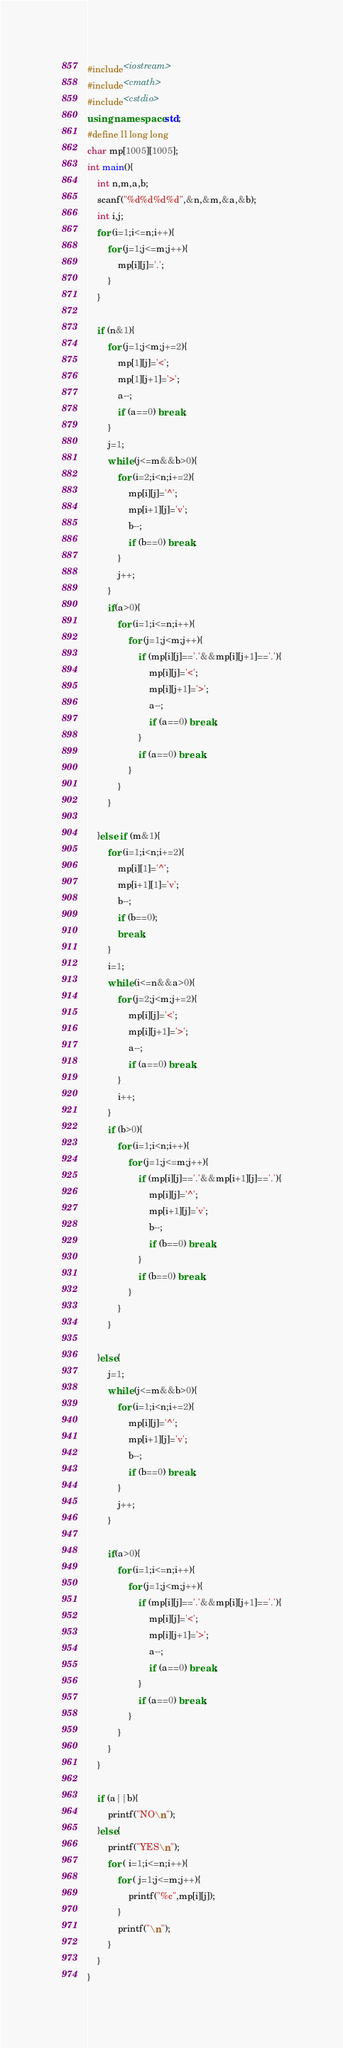Convert code to text. <code><loc_0><loc_0><loc_500><loc_500><_C++_>#include<iostream>
#include<cmath>
#include<cstdio>
using namespace std;
#define ll long long 
char mp[1005][1005];
int main(){
	int n,m,a,b;
	scanf("%d%d%d%d",&n,&m,&a,&b);
	int i,j;
	for (i=1;i<=n;i++){
		for (j=1;j<=m;j++){
			mp[i][j]='.';
		}
	}
	
	if (n&1){
		for (j=1;j<m;j+=2){
			mp[1][j]='<';
			mp[1][j+1]='>';
			a--;
			if (a==0) break;
		}
		j=1;
		while (j<=m&&b>0){
			for (i=2;i<n;i+=2){
				mp[i][j]='^';
				mp[i+1][j]='v';
				b--;
				if (b==0) break;
			}
			j++;
		}
		if(a>0){
			for (i=1;i<=n;i++){
				for (j=1;j<m;j++){
					if (mp[i][j]=='.'&&mp[i][j+1]=='.'){
						mp[i][j]='<';
						mp[i][j+1]='>';
						a--;
						if (a==0) break;
					}
					if (a==0) break;
				}
			}
		}
		
	}else if (m&1){
		for (i=1;i<n;i+=2){
			mp[i][1]='^';
			mp[i+1][1]='v';
			b--;
			if (b==0);
			break;
		}
		i=1;
		while (i<=n&&a>0){
			for (j=2;j<m;j+=2){
				mp[i][j]='<';
				mp[i][j+1]='>';
				a--;
				if (a==0) break;
			}
			i++;
		}
		if (b>0){
			for (i=1;i<n;i++){
				for (j=1;j<=m;j++){
					if (mp[i][j]=='.'&&mp[i+1][j]=='.'){
						mp[i][j]='^';
						mp[i+1][j]='v';
						b--;
						if (b==0) break;
					}
					if (b==0) break;
				}
			}
		}
		
	}else{
		j=1;
		while (j<=m&&b>0){
			for (i=1;i<n;i+=2){
				mp[i][j]='^';
				mp[i+1][j]='v';
				b--;
				if (b==0) break;
			}
			j++;
		}
		
		if(a>0){
			for (i=1;i<=n;i++){
				for (j=1;j<m;j++){
					if (mp[i][j]=='.'&&mp[i][j+1]=='.'){
						mp[i][j]='<';
						mp[i][j+1]='>';
						a--;
						if (a==0) break;
					}
					if (a==0) break;
				}
			}
		}
	}
	
	if (a||b){
		printf("NO\n");
	}else{
		printf("YES\n");
		for ( i=1;i<=n;i++){
			for ( j=1;j<=m;j++){
				printf("%c",mp[i][j]);
			}
			printf("\n");
		}
	}
}</code> 